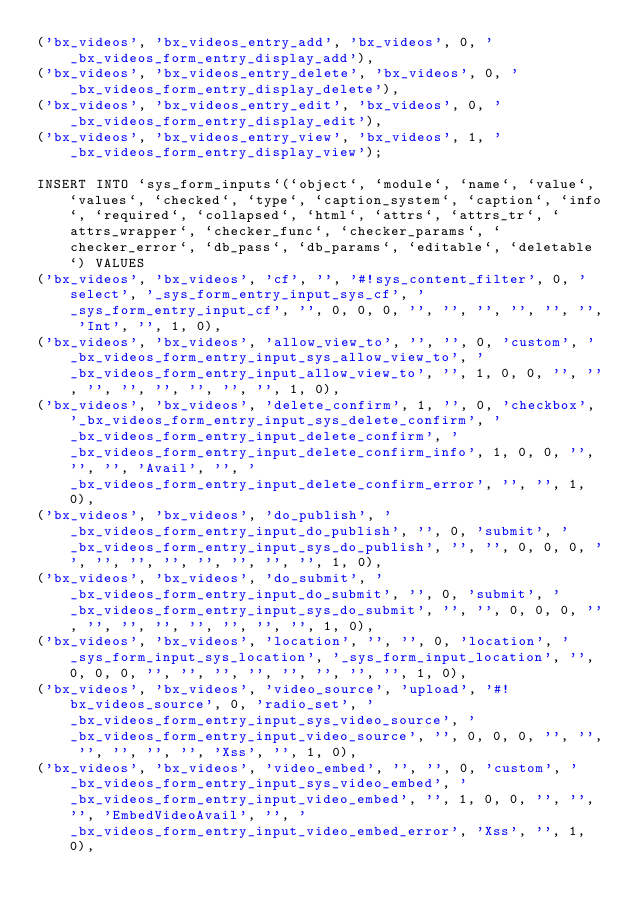Convert code to text. <code><loc_0><loc_0><loc_500><loc_500><_SQL_>('bx_videos', 'bx_videos_entry_add', 'bx_videos', 0, '_bx_videos_form_entry_display_add'),
('bx_videos', 'bx_videos_entry_delete', 'bx_videos', 0, '_bx_videos_form_entry_display_delete'),
('bx_videos', 'bx_videos_entry_edit', 'bx_videos', 0, '_bx_videos_form_entry_display_edit'),
('bx_videos', 'bx_videos_entry_view', 'bx_videos', 1, '_bx_videos_form_entry_display_view');

INSERT INTO `sys_form_inputs`(`object`, `module`, `name`, `value`, `values`, `checked`, `type`, `caption_system`, `caption`, `info`, `required`, `collapsed`, `html`, `attrs`, `attrs_tr`, `attrs_wrapper`, `checker_func`, `checker_params`, `checker_error`, `db_pass`, `db_params`, `editable`, `deletable`) VALUES 
('bx_videos', 'bx_videos', 'cf', '', '#!sys_content_filter', 0, 'select', '_sys_form_entry_input_sys_cf', '_sys_form_entry_input_cf', '', 0, 0, 0, '', '', '', '', '', '', 'Int', '', 1, 0),
('bx_videos', 'bx_videos', 'allow_view_to', '', '', 0, 'custom', '_bx_videos_form_entry_input_sys_allow_view_to', '_bx_videos_form_entry_input_allow_view_to', '', 1, 0, 0, '', '', '', '', '', '', '', '', 1, 0),
('bx_videos', 'bx_videos', 'delete_confirm', 1, '', 0, 'checkbox', '_bx_videos_form_entry_input_sys_delete_confirm', '_bx_videos_form_entry_input_delete_confirm', '_bx_videos_form_entry_input_delete_confirm_info', 1, 0, 0, '', '', '', 'Avail', '', '_bx_videos_form_entry_input_delete_confirm_error', '', '', 1, 0),
('bx_videos', 'bx_videos', 'do_publish', '_bx_videos_form_entry_input_do_publish', '', 0, 'submit', '_bx_videos_form_entry_input_sys_do_publish', '', '', 0, 0, 0, '', '', '', '', '', '', '', '', 1, 0),
('bx_videos', 'bx_videos', 'do_submit', '_bx_videos_form_entry_input_do_submit', '', 0, 'submit', '_bx_videos_form_entry_input_sys_do_submit', '', '', 0, 0, 0, '', '', '', '', '', '', '', '', 1, 0),
('bx_videos', 'bx_videos', 'location', '', '', 0, 'location', '_sys_form_input_sys_location', '_sys_form_input_location', '', 0, 0, 0, '', '', '', '', '', '', '', '', 1, 0),
('bx_videos', 'bx_videos', 'video_source', 'upload', '#!bx_videos_source', 0, 'radio_set', '_bx_videos_form_entry_input_sys_video_source', '_bx_videos_form_entry_input_video_source', '', 0, 0, 0, '', '', '', '', '', '', 'Xss', '', 1, 0),
('bx_videos', 'bx_videos', 'video_embed', '', '', 0, 'custom', '_bx_videos_form_entry_input_sys_video_embed', '_bx_videos_form_entry_input_video_embed', '', 1, 0, 0, '', '', '', 'EmbedVideoAvail', '', '_bx_videos_form_entry_input_video_embed_error', 'Xss', '', 1, 0),</code> 